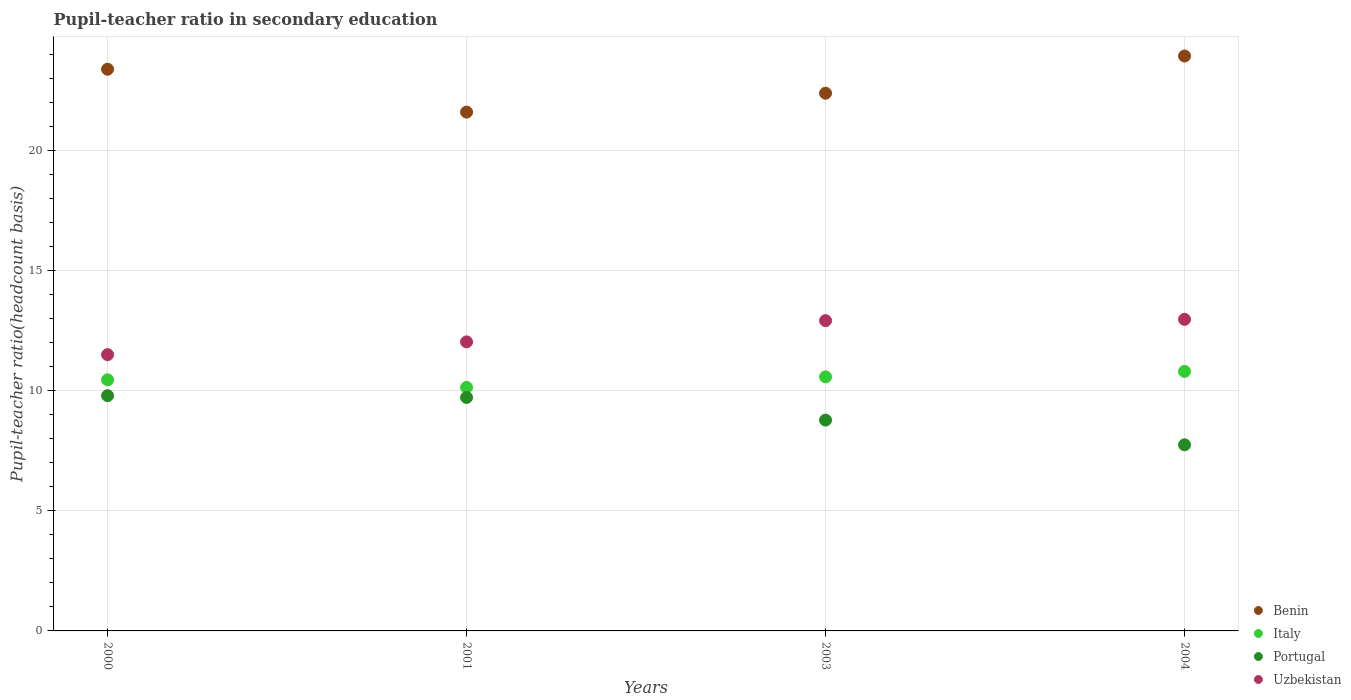How many different coloured dotlines are there?
Provide a succinct answer. 4. What is the pupil-teacher ratio in secondary education in Italy in 2000?
Keep it short and to the point. 10.45. Across all years, what is the maximum pupil-teacher ratio in secondary education in Benin?
Keep it short and to the point. 23.93. Across all years, what is the minimum pupil-teacher ratio in secondary education in Portugal?
Your answer should be compact. 7.75. In which year was the pupil-teacher ratio in secondary education in Benin minimum?
Give a very brief answer. 2001. What is the total pupil-teacher ratio in secondary education in Uzbekistan in the graph?
Offer a terse response. 49.42. What is the difference between the pupil-teacher ratio in secondary education in Uzbekistan in 2001 and that in 2004?
Your answer should be very brief. -0.94. What is the difference between the pupil-teacher ratio in secondary education in Portugal in 2004 and the pupil-teacher ratio in secondary education in Benin in 2003?
Your response must be concise. -14.64. What is the average pupil-teacher ratio in secondary education in Portugal per year?
Ensure brevity in your answer.  9.01. In the year 2000, what is the difference between the pupil-teacher ratio in secondary education in Benin and pupil-teacher ratio in secondary education in Italy?
Your answer should be compact. 12.93. What is the ratio of the pupil-teacher ratio in secondary education in Portugal in 2003 to that in 2004?
Your answer should be compact. 1.13. What is the difference between the highest and the second highest pupil-teacher ratio in secondary education in Uzbekistan?
Make the answer very short. 0.05. What is the difference between the highest and the lowest pupil-teacher ratio in secondary education in Italy?
Provide a succinct answer. 0.66. Is the sum of the pupil-teacher ratio in secondary education in Portugal in 2000 and 2003 greater than the maximum pupil-teacher ratio in secondary education in Benin across all years?
Ensure brevity in your answer.  No. Is it the case that in every year, the sum of the pupil-teacher ratio in secondary education in Benin and pupil-teacher ratio in secondary education in Italy  is greater than the sum of pupil-teacher ratio in secondary education in Portugal and pupil-teacher ratio in secondary education in Uzbekistan?
Keep it short and to the point. Yes. Is it the case that in every year, the sum of the pupil-teacher ratio in secondary education in Portugal and pupil-teacher ratio in secondary education in Uzbekistan  is greater than the pupil-teacher ratio in secondary education in Benin?
Provide a short and direct response. No. Does the pupil-teacher ratio in secondary education in Uzbekistan monotonically increase over the years?
Offer a terse response. Yes. Is the pupil-teacher ratio in secondary education in Italy strictly less than the pupil-teacher ratio in secondary education in Uzbekistan over the years?
Offer a terse response. Yes. How many dotlines are there?
Give a very brief answer. 4. What is the difference between two consecutive major ticks on the Y-axis?
Give a very brief answer. 5. Are the values on the major ticks of Y-axis written in scientific E-notation?
Offer a terse response. No. Does the graph contain any zero values?
Keep it short and to the point. No. Does the graph contain grids?
Provide a succinct answer. Yes. How are the legend labels stacked?
Make the answer very short. Vertical. What is the title of the graph?
Provide a succinct answer. Pupil-teacher ratio in secondary education. Does "Burkina Faso" appear as one of the legend labels in the graph?
Offer a very short reply. No. What is the label or title of the Y-axis?
Offer a terse response. Pupil-teacher ratio(headcount basis). What is the Pupil-teacher ratio(headcount basis) of Benin in 2000?
Make the answer very short. 23.38. What is the Pupil-teacher ratio(headcount basis) of Italy in 2000?
Give a very brief answer. 10.45. What is the Pupil-teacher ratio(headcount basis) in Portugal in 2000?
Offer a very short reply. 9.79. What is the Pupil-teacher ratio(headcount basis) in Uzbekistan in 2000?
Ensure brevity in your answer.  11.5. What is the Pupil-teacher ratio(headcount basis) in Benin in 2001?
Offer a terse response. 21.6. What is the Pupil-teacher ratio(headcount basis) in Italy in 2001?
Provide a succinct answer. 10.14. What is the Pupil-teacher ratio(headcount basis) in Portugal in 2001?
Keep it short and to the point. 9.72. What is the Pupil-teacher ratio(headcount basis) of Uzbekistan in 2001?
Your answer should be compact. 12.03. What is the Pupil-teacher ratio(headcount basis) in Benin in 2003?
Provide a short and direct response. 22.38. What is the Pupil-teacher ratio(headcount basis) in Italy in 2003?
Offer a very short reply. 10.58. What is the Pupil-teacher ratio(headcount basis) in Portugal in 2003?
Provide a short and direct response. 8.78. What is the Pupil-teacher ratio(headcount basis) of Uzbekistan in 2003?
Keep it short and to the point. 12.92. What is the Pupil-teacher ratio(headcount basis) of Benin in 2004?
Keep it short and to the point. 23.93. What is the Pupil-teacher ratio(headcount basis) in Italy in 2004?
Your response must be concise. 10.8. What is the Pupil-teacher ratio(headcount basis) in Portugal in 2004?
Provide a short and direct response. 7.75. What is the Pupil-teacher ratio(headcount basis) in Uzbekistan in 2004?
Your response must be concise. 12.97. Across all years, what is the maximum Pupil-teacher ratio(headcount basis) of Benin?
Keep it short and to the point. 23.93. Across all years, what is the maximum Pupil-teacher ratio(headcount basis) of Italy?
Provide a short and direct response. 10.8. Across all years, what is the maximum Pupil-teacher ratio(headcount basis) of Portugal?
Provide a short and direct response. 9.79. Across all years, what is the maximum Pupil-teacher ratio(headcount basis) of Uzbekistan?
Make the answer very short. 12.97. Across all years, what is the minimum Pupil-teacher ratio(headcount basis) of Benin?
Give a very brief answer. 21.6. Across all years, what is the minimum Pupil-teacher ratio(headcount basis) in Italy?
Your answer should be compact. 10.14. Across all years, what is the minimum Pupil-teacher ratio(headcount basis) of Portugal?
Your answer should be very brief. 7.75. Across all years, what is the minimum Pupil-teacher ratio(headcount basis) in Uzbekistan?
Your answer should be very brief. 11.5. What is the total Pupil-teacher ratio(headcount basis) in Benin in the graph?
Offer a very short reply. 91.3. What is the total Pupil-teacher ratio(headcount basis) in Italy in the graph?
Your answer should be very brief. 41.97. What is the total Pupil-teacher ratio(headcount basis) in Portugal in the graph?
Make the answer very short. 36.04. What is the total Pupil-teacher ratio(headcount basis) of Uzbekistan in the graph?
Offer a very short reply. 49.42. What is the difference between the Pupil-teacher ratio(headcount basis) of Benin in 2000 and that in 2001?
Keep it short and to the point. 1.78. What is the difference between the Pupil-teacher ratio(headcount basis) of Italy in 2000 and that in 2001?
Your answer should be compact. 0.31. What is the difference between the Pupil-teacher ratio(headcount basis) of Portugal in 2000 and that in 2001?
Make the answer very short. 0.07. What is the difference between the Pupil-teacher ratio(headcount basis) in Uzbekistan in 2000 and that in 2001?
Your response must be concise. -0.53. What is the difference between the Pupil-teacher ratio(headcount basis) in Italy in 2000 and that in 2003?
Provide a succinct answer. -0.12. What is the difference between the Pupil-teacher ratio(headcount basis) of Portugal in 2000 and that in 2003?
Make the answer very short. 1.02. What is the difference between the Pupil-teacher ratio(headcount basis) in Uzbekistan in 2000 and that in 2003?
Your answer should be very brief. -1.42. What is the difference between the Pupil-teacher ratio(headcount basis) in Benin in 2000 and that in 2004?
Give a very brief answer. -0.55. What is the difference between the Pupil-teacher ratio(headcount basis) of Italy in 2000 and that in 2004?
Your response must be concise. -0.35. What is the difference between the Pupil-teacher ratio(headcount basis) in Portugal in 2000 and that in 2004?
Your response must be concise. 2.05. What is the difference between the Pupil-teacher ratio(headcount basis) of Uzbekistan in 2000 and that in 2004?
Your answer should be compact. -1.47. What is the difference between the Pupil-teacher ratio(headcount basis) of Benin in 2001 and that in 2003?
Provide a short and direct response. -0.79. What is the difference between the Pupil-teacher ratio(headcount basis) in Italy in 2001 and that in 2003?
Provide a succinct answer. -0.44. What is the difference between the Pupil-teacher ratio(headcount basis) in Portugal in 2001 and that in 2003?
Ensure brevity in your answer.  0.94. What is the difference between the Pupil-teacher ratio(headcount basis) of Uzbekistan in 2001 and that in 2003?
Provide a succinct answer. -0.88. What is the difference between the Pupil-teacher ratio(headcount basis) of Benin in 2001 and that in 2004?
Provide a succinct answer. -2.34. What is the difference between the Pupil-teacher ratio(headcount basis) of Italy in 2001 and that in 2004?
Offer a terse response. -0.66. What is the difference between the Pupil-teacher ratio(headcount basis) in Portugal in 2001 and that in 2004?
Your response must be concise. 1.97. What is the difference between the Pupil-teacher ratio(headcount basis) in Uzbekistan in 2001 and that in 2004?
Your response must be concise. -0.94. What is the difference between the Pupil-teacher ratio(headcount basis) in Benin in 2003 and that in 2004?
Make the answer very short. -1.55. What is the difference between the Pupil-teacher ratio(headcount basis) of Italy in 2003 and that in 2004?
Give a very brief answer. -0.23. What is the difference between the Pupil-teacher ratio(headcount basis) of Portugal in 2003 and that in 2004?
Make the answer very short. 1.03. What is the difference between the Pupil-teacher ratio(headcount basis) of Uzbekistan in 2003 and that in 2004?
Your response must be concise. -0.05. What is the difference between the Pupil-teacher ratio(headcount basis) in Benin in 2000 and the Pupil-teacher ratio(headcount basis) in Italy in 2001?
Provide a succinct answer. 13.24. What is the difference between the Pupil-teacher ratio(headcount basis) of Benin in 2000 and the Pupil-teacher ratio(headcount basis) of Portugal in 2001?
Ensure brevity in your answer.  13.66. What is the difference between the Pupil-teacher ratio(headcount basis) of Benin in 2000 and the Pupil-teacher ratio(headcount basis) of Uzbekistan in 2001?
Keep it short and to the point. 11.35. What is the difference between the Pupil-teacher ratio(headcount basis) in Italy in 2000 and the Pupil-teacher ratio(headcount basis) in Portugal in 2001?
Ensure brevity in your answer.  0.73. What is the difference between the Pupil-teacher ratio(headcount basis) of Italy in 2000 and the Pupil-teacher ratio(headcount basis) of Uzbekistan in 2001?
Ensure brevity in your answer.  -1.58. What is the difference between the Pupil-teacher ratio(headcount basis) of Portugal in 2000 and the Pupil-teacher ratio(headcount basis) of Uzbekistan in 2001?
Ensure brevity in your answer.  -2.24. What is the difference between the Pupil-teacher ratio(headcount basis) of Benin in 2000 and the Pupil-teacher ratio(headcount basis) of Italy in 2003?
Your answer should be compact. 12.81. What is the difference between the Pupil-teacher ratio(headcount basis) in Benin in 2000 and the Pupil-teacher ratio(headcount basis) in Portugal in 2003?
Your answer should be very brief. 14.61. What is the difference between the Pupil-teacher ratio(headcount basis) of Benin in 2000 and the Pupil-teacher ratio(headcount basis) of Uzbekistan in 2003?
Your answer should be compact. 10.47. What is the difference between the Pupil-teacher ratio(headcount basis) of Italy in 2000 and the Pupil-teacher ratio(headcount basis) of Portugal in 2003?
Your answer should be very brief. 1.68. What is the difference between the Pupil-teacher ratio(headcount basis) of Italy in 2000 and the Pupil-teacher ratio(headcount basis) of Uzbekistan in 2003?
Your answer should be very brief. -2.46. What is the difference between the Pupil-teacher ratio(headcount basis) in Portugal in 2000 and the Pupil-teacher ratio(headcount basis) in Uzbekistan in 2003?
Offer a very short reply. -3.12. What is the difference between the Pupil-teacher ratio(headcount basis) of Benin in 2000 and the Pupil-teacher ratio(headcount basis) of Italy in 2004?
Provide a succinct answer. 12.58. What is the difference between the Pupil-teacher ratio(headcount basis) of Benin in 2000 and the Pupil-teacher ratio(headcount basis) of Portugal in 2004?
Your answer should be compact. 15.64. What is the difference between the Pupil-teacher ratio(headcount basis) of Benin in 2000 and the Pupil-teacher ratio(headcount basis) of Uzbekistan in 2004?
Your response must be concise. 10.41. What is the difference between the Pupil-teacher ratio(headcount basis) in Italy in 2000 and the Pupil-teacher ratio(headcount basis) in Portugal in 2004?
Provide a short and direct response. 2.71. What is the difference between the Pupil-teacher ratio(headcount basis) of Italy in 2000 and the Pupil-teacher ratio(headcount basis) of Uzbekistan in 2004?
Give a very brief answer. -2.52. What is the difference between the Pupil-teacher ratio(headcount basis) of Portugal in 2000 and the Pupil-teacher ratio(headcount basis) of Uzbekistan in 2004?
Ensure brevity in your answer.  -3.18. What is the difference between the Pupil-teacher ratio(headcount basis) of Benin in 2001 and the Pupil-teacher ratio(headcount basis) of Italy in 2003?
Your answer should be very brief. 11.02. What is the difference between the Pupil-teacher ratio(headcount basis) of Benin in 2001 and the Pupil-teacher ratio(headcount basis) of Portugal in 2003?
Provide a short and direct response. 12.82. What is the difference between the Pupil-teacher ratio(headcount basis) in Benin in 2001 and the Pupil-teacher ratio(headcount basis) in Uzbekistan in 2003?
Give a very brief answer. 8.68. What is the difference between the Pupil-teacher ratio(headcount basis) of Italy in 2001 and the Pupil-teacher ratio(headcount basis) of Portugal in 2003?
Your answer should be compact. 1.36. What is the difference between the Pupil-teacher ratio(headcount basis) of Italy in 2001 and the Pupil-teacher ratio(headcount basis) of Uzbekistan in 2003?
Your answer should be compact. -2.78. What is the difference between the Pupil-teacher ratio(headcount basis) of Portugal in 2001 and the Pupil-teacher ratio(headcount basis) of Uzbekistan in 2003?
Offer a very short reply. -3.2. What is the difference between the Pupil-teacher ratio(headcount basis) in Benin in 2001 and the Pupil-teacher ratio(headcount basis) in Italy in 2004?
Your answer should be compact. 10.79. What is the difference between the Pupil-teacher ratio(headcount basis) of Benin in 2001 and the Pupil-teacher ratio(headcount basis) of Portugal in 2004?
Offer a terse response. 13.85. What is the difference between the Pupil-teacher ratio(headcount basis) of Benin in 2001 and the Pupil-teacher ratio(headcount basis) of Uzbekistan in 2004?
Offer a very short reply. 8.63. What is the difference between the Pupil-teacher ratio(headcount basis) of Italy in 2001 and the Pupil-teacher ratio(headcount basis) of Portugal in 2004?
Provide a succinct answer. 2.39. What is the difference between the Pupil-teacher ratio(headcount basis) of Italy in 2001 and the Pupil-teacher ratio(headcount basis) of Uzbekistan in 2004?
Keep it short and to the point. -2.83. What is the difference between the Pupil-teacher ratio(headcount basis) of Portugal in 2001 and the Pupil-teacher ratio(headcount basis) of Uzbekistan in 2004?
Your response must be concise. -3.25. What is the difference between the Pupil-teacher ratio(headcount basis) in Benin in 2003 and the Pupil-teacher ratio(headcount basis) in Italy in 2004?
Make the answer very short. 11.58. What is the difference between the Pupil-teacher ratio(headcount basis) of Benin in 2003 and the Pupil-teacher ratio(headcount basis) of Portugal in 2004?
Your response must be concise. 14.64. What is the difference between the Pupil-teacher ratio(headcount basis) in Benin in 2003 and the Pupil-teacher ratio(headcount basis) in Uzbekistan in 2004?
Make the answer very short. 9.41. What is the difference between the Pupil-teacher ratio(headcount basis) in Italy in 2003 and the Pupil-teacher ratio(headcount basis) in Portugal in 2004?
Your answer should be compact. 2.83. What is the difference between the Pupil-teacher ratio(headcount basis) of Italy in 2003 and the Pupil-teacher ratio(headcount basis) of Uzbekistan in 2004?
Your answer should be very brief. -2.4. What is the difference between the Pupil-teacher ratio(headcount basis) in Portugal in 2003 and the Pupil-teacher ratio(headcount basis) in Uzbekistan in 2004?
Provide a succinct answer. -4.2. What is the average Pupil-teacher ratio(headcount basis) of Benin per year?
Give a very brief answer. 22.83. What is the average Pupil-teacher ratio(headcount basis) in Italy per year?
Your response must be concise. 10.49. What is the average Pupil-teacher ratio(headcount basis) of Portugal per year?
Provide a short and direct response. 9.01. What is the average Pupil-teacher ratio(headcount basis) of Uzbekistan per year?
Provide a succinct answer. 12.36. In the year 2000, what is the difference between the Pupil-teacher ratio(headcount basis) in Benin and Pupil-teacher ratio(headcount basis) in Italy?
Your answer should be very brief. 12.93. In the year 2000, what is the difference between the Pupil-teacher ratio(headcount basis) in Benin and Pupil-teacher ratio(headcount basis) in Portugal?
Your answer should be compact. 13.59. In the year 2000, what is the difference between the Pupil-teacher ratio(headcount basis) of Benin and Pupil-teacher ratio(headcount basis) of Uzbekistan?
Keep it short and to the point. 11.88. In the year 2000, what is the difference between the Pupil-teacher ratio(headcount basis) in Italy and Pupil-teacher ratio(headcount basis) in Portugal?
Your answer should be very brief. 0.66. In the year 2000, what is the difference between the Pupil-teacher ratio(headcount basis) in Italy and Pupil-teacher ratio(headcount basis) in Uzbekistan?
Ensure brevity in your answer.  -1.05. In the year 2000, what is the difference between the Pupil-teacher ratio(headcount basis) of Portugal and Pupil-teacher ratio(headcount basis) of Uzbekistan?
Make the answer very short. -1.71. In the year 2001, what is the difference between the Pupil-teacher ratio(headcount basis) of Benin and Pupil-teacher ratio(headcount basis) of Italy?
Your answer should be compact. 11.46. In the year 2001, what is the difference between the Pupil-teacher ratio(headcount basis) in Benin and Pupil-teacher ratio(headcount basis) in Portugal?
Provide a short and direct response. 11.88. In the year 2001, what is the difference between the Pupil-teacher ratio(headcount basis) in Benin and Pupil-teacher ratio(headcount basis) in Uzbekistan?
Make the answer very short. 9.57. In the year 2001, what is the difference between the Pupil-teacher ratio(headcount basis) in Italy and Pupil-teacher ratio(headcount basis) in Portugal?
Offer a terse response. 0.42. In the year 2001, what is the difference between the Pupil-teacher ratio(headcount basis) of Italy and Pupil-teacher ratio(headcount basis) of Uzbekistan?
Your answer should be compact. -1.89. In the year 2001, what is the difference between the Pupil-teacher ratio(headcount basis) of Portugal and Pupil-teacher ratio(headcount basis) of Uzbekistan?
Your answer should be very brief. -2.31. In the year 2003, what is the difference between the Pupil-teacher ratio(headcount basis) of Benin and Pupil-teacher ratio(headcount basis) of Italy?
Your answer should be compact. 11.81. In the year 2003, what is the difference between the Pupil-teacher ratio(headcount basis) of Benin and Pupil-teacher ratio(headcount basis) of Portugal?
Give a very brief answer. 13.61. In the year 2003, what is the difference between the Pupil-teacher ratio(headcount basis) of Benin and Pupil-teacher ratio(headcount basis) of Uzbekistan?
Your answer should be compact. 9.47. In the year 2003, what is the difference between the Pupil-teacher ratio(headcount basis) of Italy and Pupil-teacher ratio(headcount basis) of Portugal?
Your response must be concise. 1.8. In the year 2003, what is the difference between the Pupil-teacher ratio(headcount basis) in Italy and Pupil-teacher ratio(headcount basis) in Uzbekistan?
Keep it short and to the point. -2.34. In the year 2003, what is the difference between the Pupil-teacher ratio(headcount basis) of Portugal and Pupil-teacher ratio(headcount basis) of Uzbekistan?
Give a very brief answer. -4.14. In the year 2004, what is the difference between the Pupil-teacher ratio(headcount basis) in Benin and Pupil-teacher ratio(headcount basis) in Italy?
Ensure brevity in your answer.  13.13. In the year 2004, what is the difference between the Pupil-teacher ratio(headcount basis) in Benin and Pupil-teacher ratio(headcount basis) in Portugal?
Your answer should be very brief. 16.19. In the year 2004, what is the difference between the Pupil-teacher ratio(headcount basis) of Benin and Pupil-teacher ratio(headcount basis) of Uzbekistan?
Ensure brevity in your answer.  10.96. In the year 2004, what is the difference between the Pupil-teacher ratio(headcount basis) of Italy and Pupil-teacher ratio(headcount basis) of Portugal?
Your answer should be compact. 3.06. In the year 2004, what is the difference between the Pupil-teacher ratio(headcount basis) of Italy and Pupil-teacher ratio(headcount basis) of Uzbekistan?
Your answer should be very brief. -2.17. In the year 2004, what is the difference between the Pupil-teacher ratio(headcount basis) of Portugal and Pupil-teacher ratio(headcount basis) of Uzbekistan?
Keep it short and to the point. -5.22. What is the ratio of the Pupil-teacher ratio(headcount basis) of Benin in 2000 to that in 2001?
Make the answer very short. 1.08. What is the ratio of the Pupil-teacher ratio(headcount basis) in Italy in 2000 to that in 2001?
Keep it short and to the point. 1.03. What is the ratio of the Pupil-teacher ratio(headcount basis) of Portugal in 2000 to that in 2001?
Offer a terse response. 1.01. What is the ratio of the Pupil-teacher ratio(headcount basis) of Uzbekistan in 2000 to that in 2001?
Ensure brevity in your answer.  0.96. What is the ratio of the Pupil-teacher ratio(headcount basis) of Benin in 2000 to that in 2003?
Give a very brief answer. 1.04. What is the ratio of the Pupil-teacher ratio(headcount basis) of Portugal in 2000 to that in 2003?
Give a very brief answer. 1.12. What is the ratio of the Pupil-teacher ratio(headcount basis) in Uzbekistan in 2000 to that in 2003?
Ensure brevity in your answer.  0.89. What is the ratio of the Pupil-teacher ratio(headcount basis) of Italy in 2000 to that in 2004?
Make the answer very short. 0.97. What is the ratio of the Pupil-teacher ratio(headcount basis) of Portugal in 2000 to that in 2004?
Offer a very short reply. 1.26. What is the ratio of the Pupil-teacher ratio(headcount basis) in Uzbekistan in 2000 to that in 2004?
Keep it short and to the point. 0.89. What is the ratio of the Pupil-teacher ratio(headcount basis) of Benin in 2001 to that in 2003?
Your answer should be very brief. 0.96. What is the ratio of the Pupil-teacher ratio(headcount basis) of Italy in 2001 to that in 2003?
Make the answer very short. 0.96. What is the ratio of the Pupil-teacher ratio(headcount basis) in Portugal in 2001 to that in 2003?
Provide a short and direct response. 1.11. What is the ratio of the Pupil-teacher ratio(headcount basis) of Uzbekistan in 2001 to that in 2003?
Offer a very short reply. 0.93. What is the ratio of the Pupil-teacher ratio(headcount basis) in Benin in 2001 to that in 2004?
Offer a terse response. 0.9. What is the ratio of the Pupil-teacher ratio(headcount basis) of Italy in 2001 to that in 2004?
Offer a terse response. 0.94. What is the ratio of the Pupil-teacher ratio(headcount basis) in Portugal in 2001 to that in 2004?
Keep it short and to the point. 1.25. What is the ratio of the Pupil-teacher ratio(headcount basis) of Uzbekistan in 2001 to that in 2004?
Ensure brevity in your answer.  0.93. What is the ratio of the Pupil-teacher ratio(headcount basis) in Benin in 2003 to that in 2004?
Ensure brevity in your answer.  0.94. What is the ratio of the Pupil-teacher ratio(headcount basis) of Italy in 2003 to that in 2004?
Your answer should be compact. 0.98. What is the ratio of the Pupil-teacher ratio(headcount basis) in Portugal in 2003 to that in 2004?
Provide a succinct answer. 1.13. What is the difference between the highest and the second highest Pupil-teacher ratio(headcount basis) of Benin?
Offer a very short reply. 0.55. What is the difference between the highest and the second highest Pupil-teacher ratio(headcount basis) in Italy?
Your answer should be compact. 0.23. What is the difference between the highest and the second highest Pupil-teacher ratio(headcount basis) in Portugal?
Give a very brief answer. 0.07. What is the difference between the highest and the second highest Pupil-teacher ratio(headcount basis) in Uzbekistan?
Your answer should be very brief. 0.05. What is the difference between the highest and the lowest Pupil-teacher ratio(headcount basis) of Benin?
Keep it short and to the point. 2.34. What is the difference between the highest and the lowest Pupil-teacher ratio(headcount basis) in Italy?
Make the answer very short. 0.66. What is the difference between the highest and the lowest Pupil-teacher ratio(headcount basis) of Portugal?
Your answer should be very brief. 2.05. What is the difference between the highest and the lowest Pupil-teacher ratio(headcount basis) in Uzbekistan?
Offer a very short reply. 1.47. 